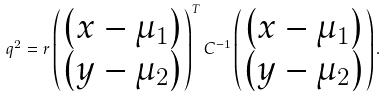Convert formula to latex. <formula><loc_0><loc_0><loc_500><loc_500>q ^ { 2 } = r \begin{pmatrix} \left ( x - \mu _ { 1 } \right ) \\ \left ( y - \mu _ { 2 } \right ) \end{pmatrix} ^ { T } C ^ { - 1 } \begin{pmatrix} \left ( x - \mu _ { 1 } \right ) \\ \left ( y - \mu _ { 2 } \right ) \end{pmatrix} .</formula> 